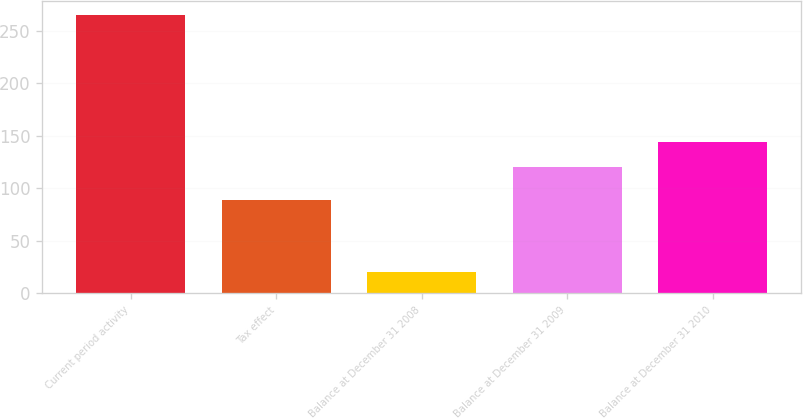Convert chart to OTSL. <chart><loc_0><loc_0><loc_500><loc_500><bar_chart><fcel>Current period activity<fcel>Tax effect<fcel>Balance at December 31 2008<fcel>Balance at December 31 2009<fcel>Balance at December 31 2010<nl><fcel>265<fcel>89<fcel>20<fcel>120<fcel>144.5<nl></chart> 